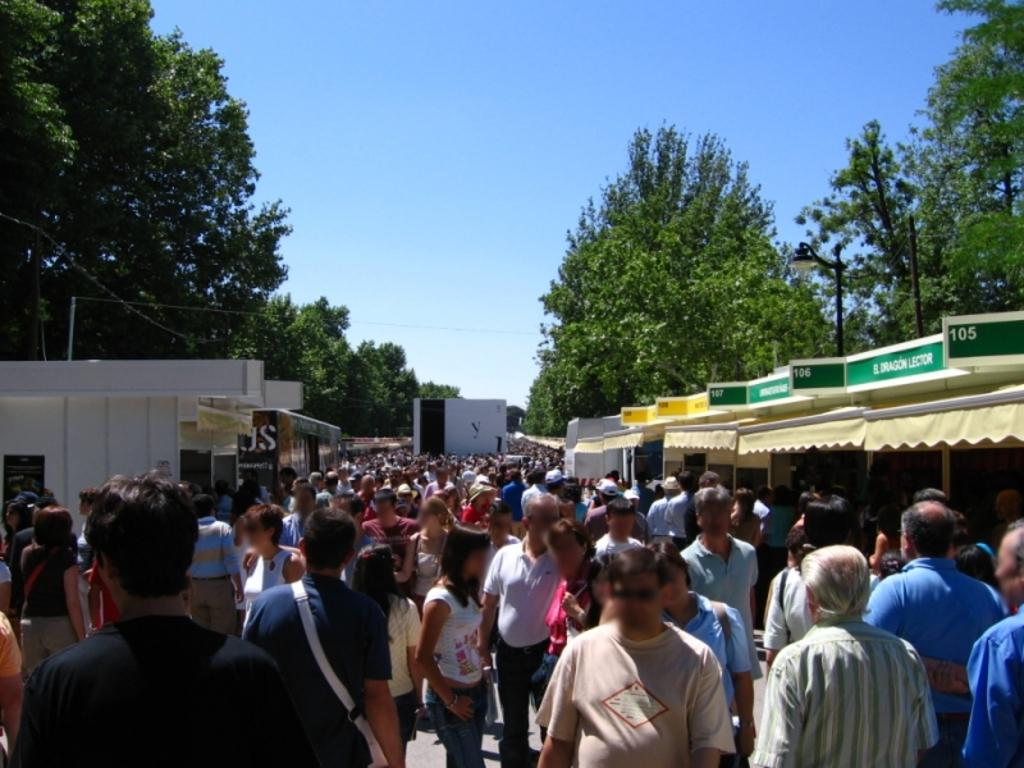What can be seen in the image? There is a crowd, stalls, a shed, poles, trees, and a blue sky in the image. What type of structure is present in the image? There is a shed in the image. What might be used for displaying information or advertisements in the image? There is a board in the image that could be used for displaying information or advertisements. What is the color of the sky in the image? The sky is blue in the image. Can you see a mint plant growing near the shed in the image? There is no mint plant visible in the image. Is there a maid serving food at one of the stalls in the image? There is no maid present in the image; it only shows a crowd, stalls, a shed, poles, trees, and a blue sky. 